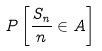<formula> <loc_0><loc_0><loc_500><loc_500>P \left [ \frac { S _ { n } } { n } \in A \right ]</formula> 